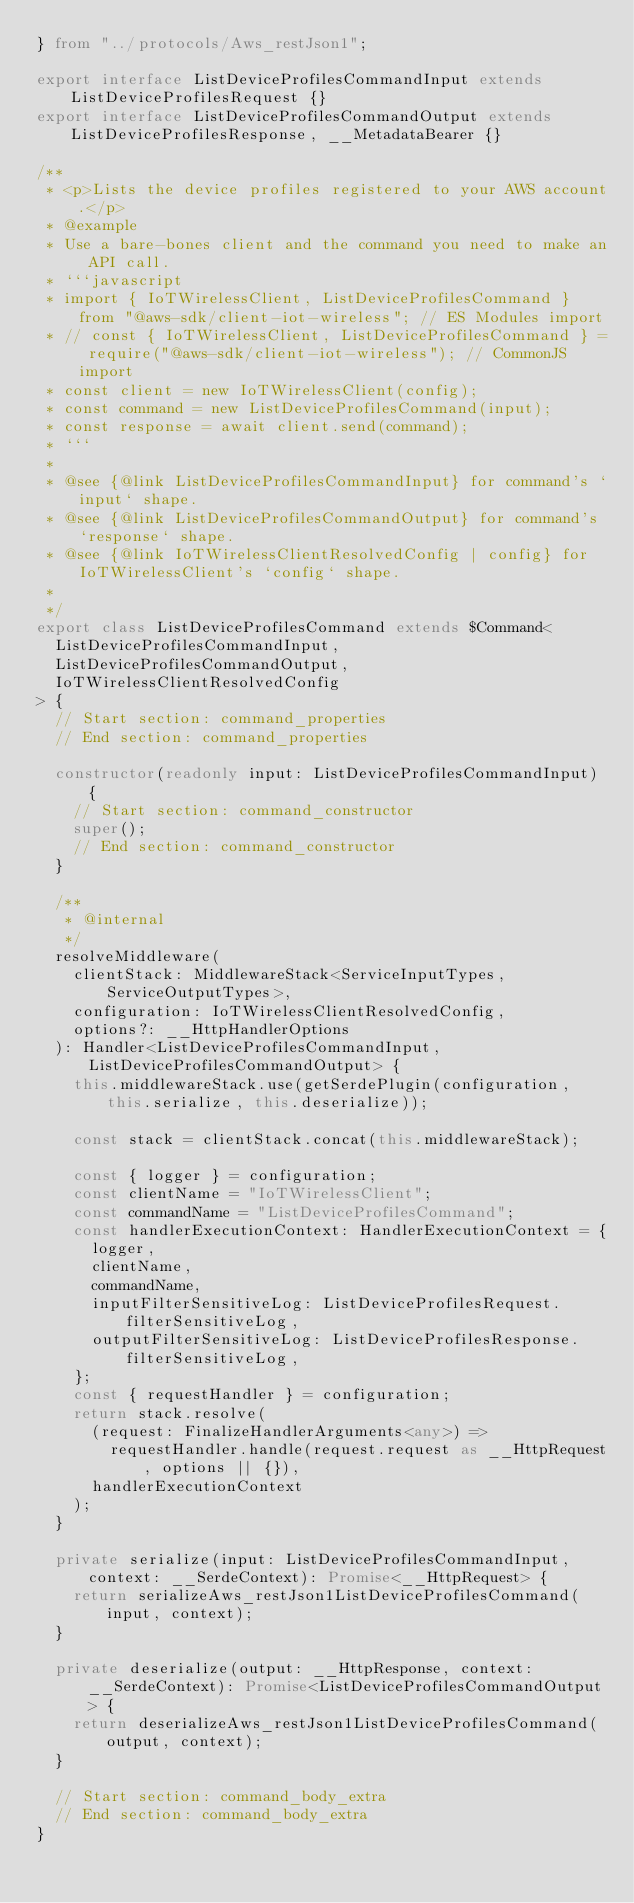<code> <loc_0><loc_0><loc_500><loc_500><_TypeScript_>} from "../protocols/Aws_restJson1";

export interface ListDeviceProfilesCommandInput extends ListDeviceProfilesRequest {}
export interface ListDeviceProfilesCommandOutput extends ListDeviceProfilesResponse, __MetadataBearer {}

/**
 * <p>Lists the device profiles registered to your AWS account.</p>
 * @example
 * Use a bare-bones client and the command you need to make an API call.
 * ```javascript
 * import { IoTWirelessClient, ListDeviceProfilesCommand } from "@aws-sdk/client-iot-wireless"; // ES Modules import
 * // const { IoTWirelessClient, ListDeviceProfilesCommand } = require("@aws-sdk/client-iot-wireless"); // CommonJS import
 * const client = new IoTWirelessClient(config);
 * const command = new ListDeviceProfilesCommand(input);
 * const response = await client.send(command);
 * ```
 *
 * @see {@link ListDeviceProfilesCommandInput} for command's `input` shape.
 * @see {@link ListDeviceProfilesCommandOutput} for command's `response` shape.
 * @see {@link IoTWirelessClientResolvedConfig | config} for IoTWirelessClient's `config` shape.
 *
 */
export class ListDeviceProfilesCommand extends $Command<
  ListDeviceProfilesCommandInput,
  ListDeviceProfilesCommandOutput,
  IoTWirelessClientResolvedConfig
> {
  // Start section: command_properties
  // End section: command_properties

  constructor(readonly input: ListDeviceProfilesCommandInput) {
    // Start section: command_constructor
    super();
    // End section: command_constructor
  }

  /**
   * @internal
   */
  resolveMiddleware(
    clientStack: MiddlewareStack<ServiceInputTypes, ServiceOutputTypes>,
    configuration: IoTWirelessClientResolvedConfig,
    options?: __HttpHandlerOptions
  ): Handler<ListDeviceProfilesCommandInput, ListDeviceProfilesCommandOutput> {
    this.middlewareStack.use(getSerdePlugin(configuration, this.serialize, this.deserialize));

    const stack = clientStack.concat(this.middlewareStack);

    const { logger } = configuration;
    const clientName = "IoTWirelessClient";
    const commandName = "ListDeviceProfilesCommand";
    const handlerExecutionContext: HandlerExecutionContext = {
      logger,
      clientName,
      commandName,
      inputFilterSensitiveLog: ListDeviceProfilesRequest.filterSensitiveLog,
      outputFilterSensitiveLog: ListDeviceProfilesResponse.filterSensitiveLog,
    };
    const { requestHandler } = configuration;
    return stack.resolve(
      (request: FinalizeHandlerArguments<any>) =>
        requestHandler.handle(request.request as __HttpRequest, options || {}),
      handlerExecutionContext
    );
  }

  private serialize(input: ListDeviceProfilesCommandInput, context: __SerdeContext): Promise<__HttpRequest> {
    return serializeAws_restJson1ListDeviceProfilesCommand(input, context);
  }

  private deserialize(output: __HttpResponse, context: __SerdeContext): Promise<ListDeviceProfilesCommandOutput> {
    return deserializeAws_restJson1ListDeviceProfilesCommand(output, context);
  }

  // Start section: command_body_extra
  // End section: command_body_extra
}
</code> 